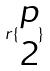Convert formula to latex. <formula><loc_0><loc_0><loc_500><loc_500>r \{ \begin{matrix} p \\ 2 \end{matrix} \}</formula> 